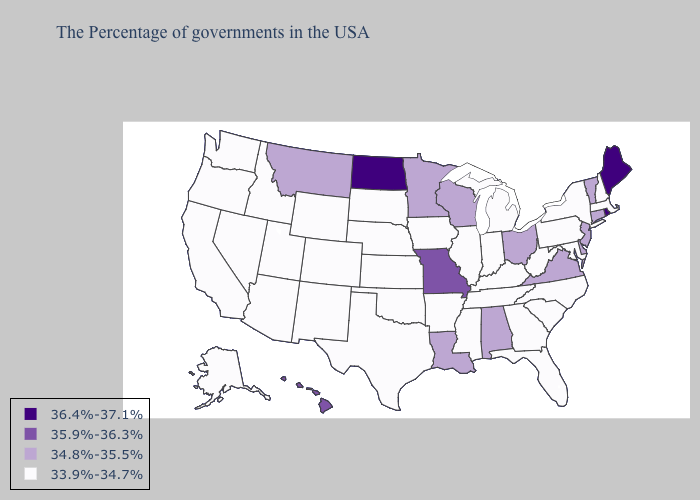What is the highest value in the USA?
Quick response, please. 36.4%-37.1%. Does the map have missing data?
Keep it brief. No. Which states hav the highest value in the West?
Be succinct. Hawaii. Does Hawaii have the lowest value in the West?
Keep it brief. No. Name the states that have a value in the range 34.8%-35.5%?
Keep it brief. Vermont, Connecticut, New Jersey, Delaware, Virginia, Ohio, Alabama, Wisconsin, Louisiana, Minnesota, Montana. Which states have the highest value in the USA?
Be succinct. Maine, Rhode Island, North Dakota. Does Hawaii have the highest value in the West?
Write a very short answer. Yes. How many symbols are there in the legend?
Short answer required. 4. Name the states that have a value in the range 35.9%-36.3%?
Quick response, please. Missouri, Hawaii. Among the states that border Connecticut , which have the highest value?
Write a very short answer. Rhode Island. Among the states that border Delaware , does Maryland have the lowest value?
Quick response, please. Yes. Name the states that have a value in the range 36.4%-37.1%?
Give a very brief answer. Maine, Rhode Island, North Dakota. Name the states that have a value in the range 36.4%-37.1%?
Short answer required. Maine, Rhode Island, North Dakota. Name the states that have a value in the range 35.9%-36.3%?
Quick response, please. Missouri, Hawaii. What is the value of Florida?
Write a very short answer. 33.9%-34.7%. 